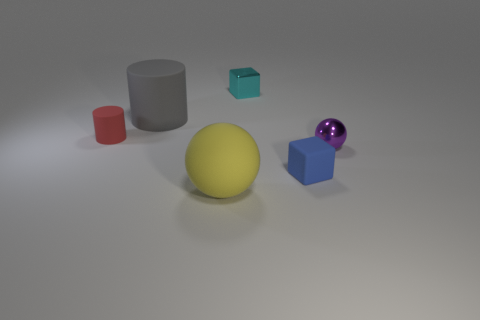Can you describe the position of the round yellow object? Certainly! The round yellow object, which appears to be a matte sphere, is centrally located in the image and in front of all the other geometric shapes. 